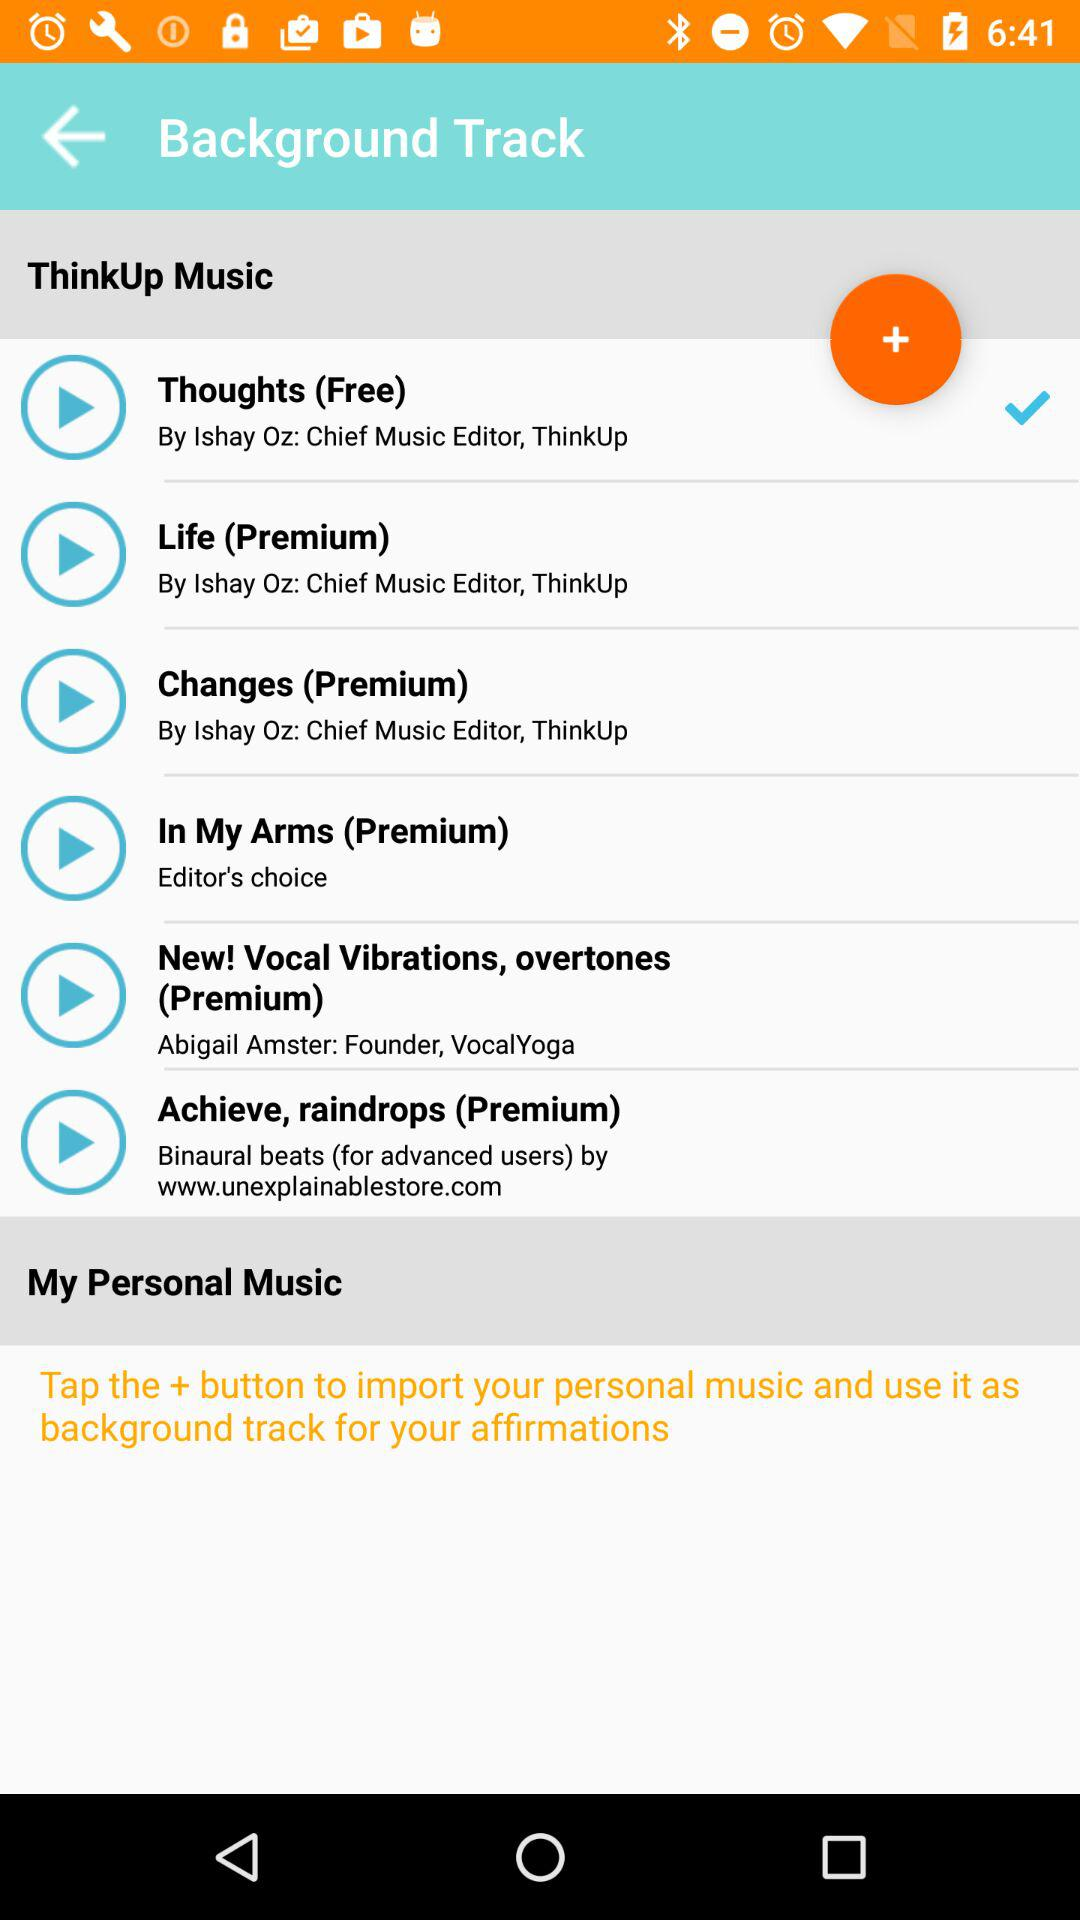How many background tracks are available to me?
Answer the question using a single word or phrase. 6 